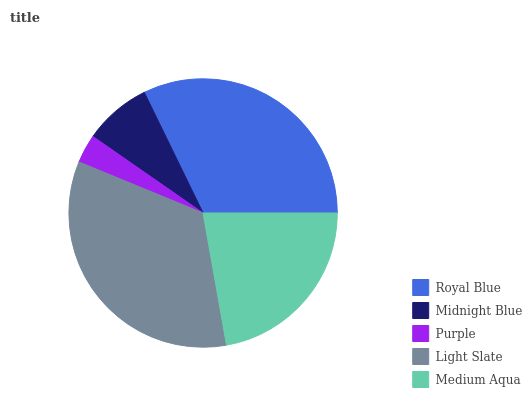Is Purple the minimum?
Answer yes or no. Yes. Is Light Slate the maximum?
Answer yes or no. Yes. Is Midnight Blue the minimum?
Answer yes or no. No. Is Midnight Blue the maximum?
Answer yes or no. No. Is Royal Blue greater than Midnight Blue?
Answer yes or no. Yes. Is Midnight Blue less than Royal Blue?
Answer yes or no. Yes. Is Midnight Blue greater than Royal Blue?
Answer yes or no. No. Is Royal Blue less than Midnight Blue?
Answer yes or no. No. Is Medium Aqua the high median?
Answer yes or no. Yes. Is Medium Aqua the low median?
Answer yes or no. Yes. Is Light Slate the high median?
Answer yes or no. No. Is Light Slate the low median?
Answer yes or no. No. 